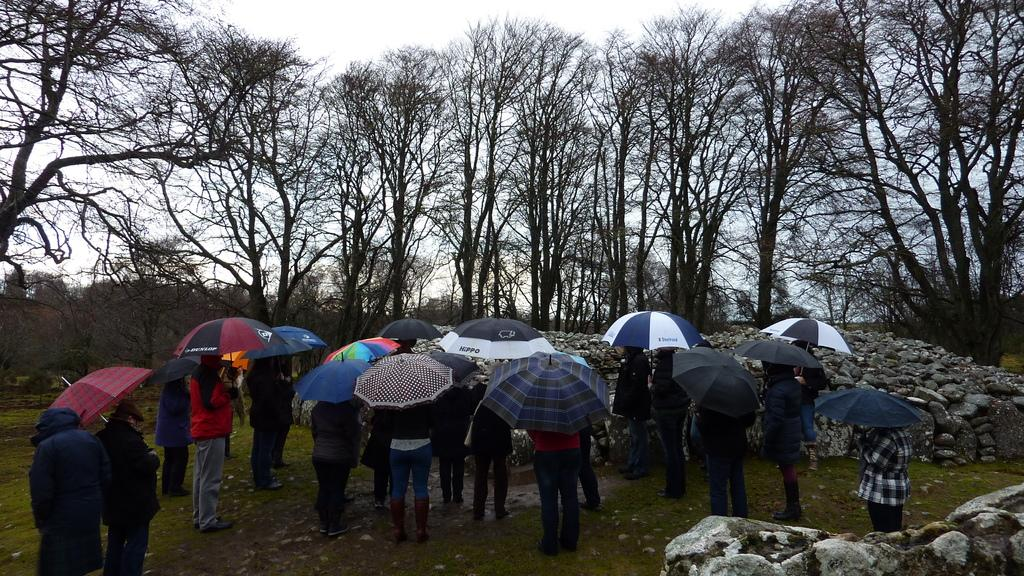How many people are in the image? There is a group of people in the image, but the exact number is not specified. Where are the people standing in the image? The people are standing in an open area in the image. What are the people holding in the image? The people are holding umbrellas in the image. What can be seen around the group of people in the image? There are many stones around the group of people in the image. What is visible behind the stones in the image? There are tall trees behind the stones in the image. What type of cheese is being served on the side in the image? There is no cheese or any food mentioned in the image; it features a group of people holding umbrellas in an open area with stones and tall trees in the background. How many clocks can be seen in the image? There are no clocks visible in the image. 